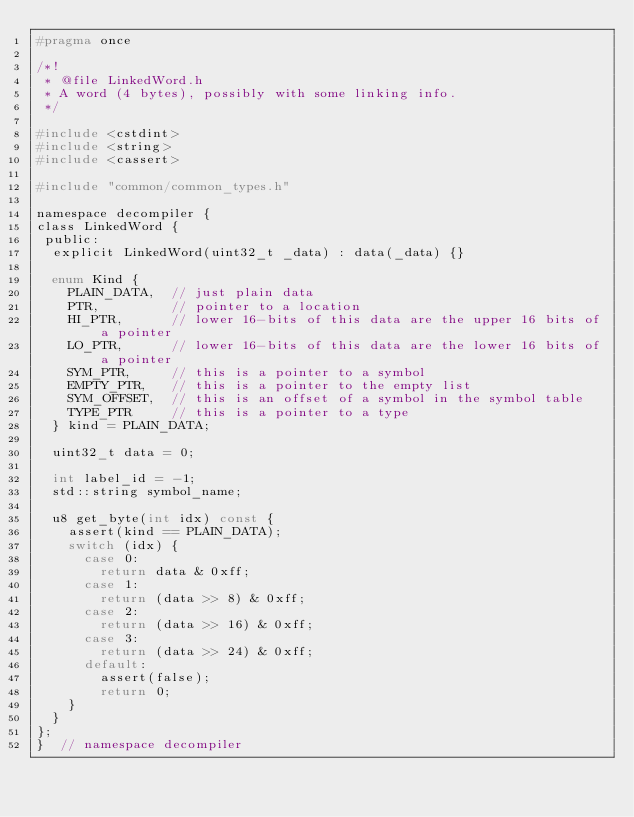Convert code to text. <code><loc_0><loc_0><loc_500><loc_500><_C_>#pragma once

/*!
 * @file LinkedWord.h
 * A word (4 bytes), possibly with some linking info.
 */

#include <cstdint>
#include <string>
#include <cassert>

#include "common/common_types.h"

namespace decompiler {
class LinkedWord {
 public:
  explicit LinkedWord(uint32_t _data) : data(_data) {}

  enum Kind {
    PLAIN_DATA,  // just plain data
    PTR,         // pointer to a location
    HI_PTR,      // lower 16-bits of this data are the upper 16 bits of a pointer
    LO_PTR,      // lower 16-bits of this data are the lower 16 bits of a pointer
    SYM_PTR,     // this is a pointer to a symbol
    EMPTY_PTR,   // this is a pointer to the empty list
    SYM_OFFSET,  // this is an offset of a symbol in the symbol table
    TYPE_PTR     // this is a pointer to a type
  } kind = PLAIN_DATA;

  uint32_t data = 0;

  int label_id = -1;
  std::string symbol_name;

  u8 get_byte(int idx) const {
    assert(kind == PLAIN_DATA);
    switch (idx) {
      case 0:
        return data & 0xff;
      case 1:
        return (data >> 8) & 0xff;
      case 2:
        return (data >> 16) & 0xff;
      case 3:
        return (data >> 24) & 0xff;
      default:
        assert(false);
        return 0;
    }
  }
};
}  // namespace decompiler
</code> 